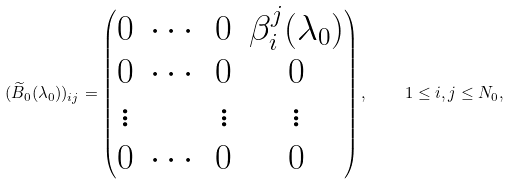Convert formula to latex. <formula><loc_0><loc_0><loc_500><loc_500>( \widetilde { B } _ { 0 } ( \lambda _ { 0 } ) ) _ { i j } = \begin{pmatrix} 0 & \cdots & 0 & \beta _ { i } ^ { j } ( \lambda _ { 0 } ) \\ 0 & \cdots & 0 & 0 \\ \vdots & & \vdots & \vdots \\ 0 & \cdots & 0 & 0 \end{pmatrix} , \quad 1 \leq i , j \leq N _ { 0 } ,</formula> 